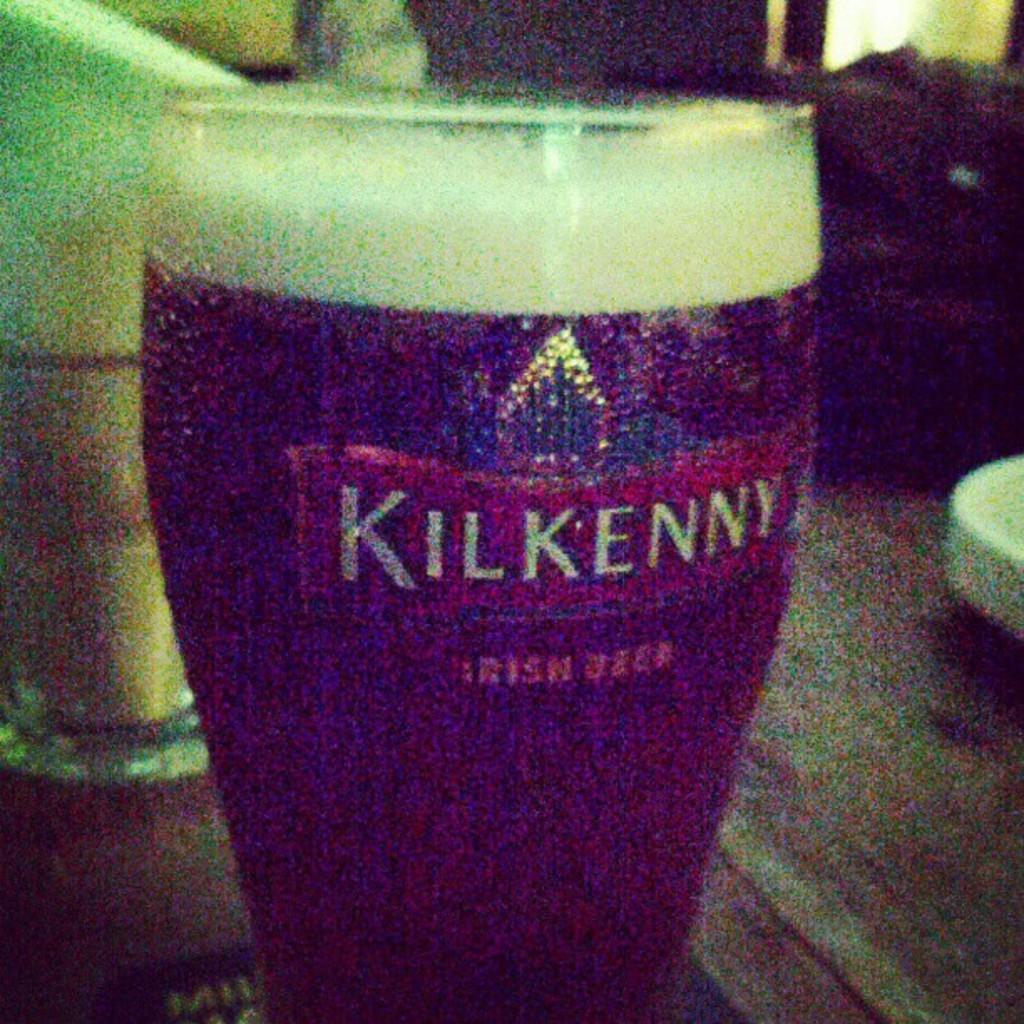What letter is in yellow?
Offer a terse response. Unanswerable. What kind of beer is it?
Make the answer very short. Kilkenny. 